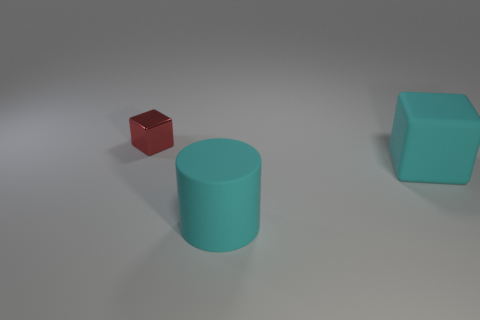Add 2 metal things. How many objects exist? 5 Subtract all rubber things. Subtract all large blue matte cubes. How many objects are left? 1 Add 3 rubber cylinders. How many rubber cylinders are left? 4 Add 3 small red shiny blocks. How many small red shiny blocks exist? 4 Subtract all cyan cubes. How many cubes are left? 1 Subtract 0 purple blocks. How many objects are left? 3 Subtract all cylinders. How many objects are left? 2 Subtract 2 cubes. How many cubes are left? 0 Subtract all cyan blocks. Subtract all cyan cylinders. How many blocks are left? 1 Subtract all cyan blocks. How many red cylinders are left? 0 